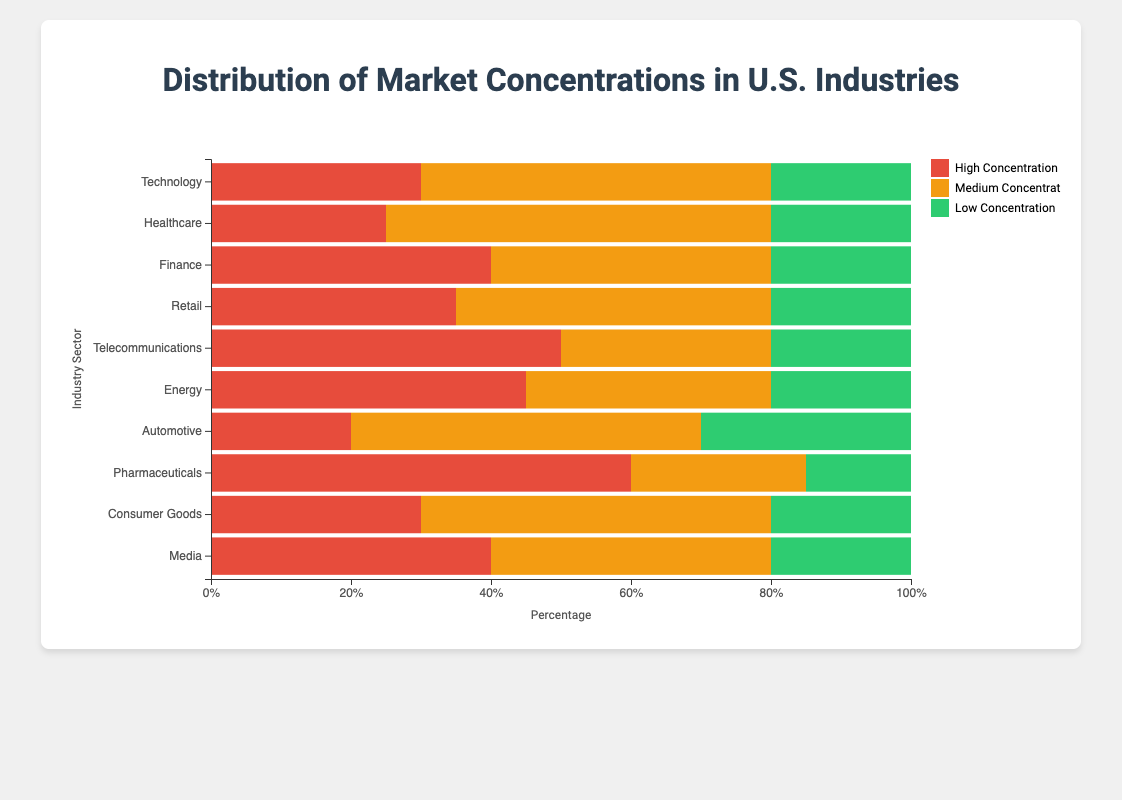Which industry has the highest percentage of high concentration? Scan the bar chart to identify the industry with the longest red section, which represents high concentration. The Pharmaceuticals industry has the longest red section.
Answer: Pharmaceuticals Which industry has the lowest percentage of medium concentration? Compare the orange sections across all industries. The Pharmaceuticals industry has the shortest orange section.
Answer: Pharmaceuticals What is the total percentage of high and medium concentration in the Telecommunications industry? Sum the percentages of high and medium concentration for Telecommunications. The values are 50% (high) + 30% (medium) = 80%.
Answer: 80% Which two industries have the same percentage of low concentration? Look at the green sections of the bars and identify industries with matching lengths. Both Technology and Healthcare have 20% in low concentration.
Answer: Technology and Healthcare How much higher is the high concentration percentage in Pharmaceuticals compared to Automotive? Subtract the high concentration percentage of Automotive from Pharmaceuticals: 60% (Pharmaceuticals) - 20% (Automotive) = 40%.
Answer: 40% Which industry has a balanced distribution with equal percentages for high, medium, and low concentrations? Scan the chart for an industry where all segments appear to be the same length. None of the industries have equal percentages for high, medium, and low concentrations.
Answer: None What is the average percentage of high concentration across all industries? Sum the high concentration percentages and divide by the number of industries: (30 + 25 + 40 + 35 + 50 + 45 + 20 + 60 + 30 + 40) / 10 = 37.5%.
Answer: 37.5% Which industry has the highest combined percentage for medium and low concentrations? Sum the medium and low concentrations for each industry and compare. Healthcare has (55 + 20) = 75%, which is the highest.
Answer: Healthcare Which industry has the smallest difference between high and low concentration percentages? Calculate the difference between high and low concentrations for each industry and find the smallest one. Finance has a difference of 40% (high) - 20% (low) = 20%.
Answer: Finance Is there an industry where medium concentration is greater than high and low concentrations combined? Compare medium concentration to the sum of high and low concentrations for each industry. No industry has medium concentration greater than the sum of high and low concentrations.
Answer: No 